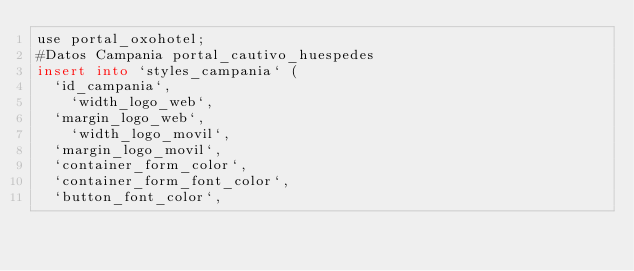<code> <loc_0><loc_0><loc_500><loc_500><_SQL_>use portal_oxohotel;
#Datos Campania portal_cautivo_huespedes
insert into `styles_campania` (
	`id_campania`, 
    `width_logo_web`,
	`margin_logo_web`,
    `width_logo_movil`,
	`margin_logo_movil`,
	`container_form_color`,
	`container_form_font_color`,
	`button_font_color`,</code> 